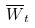Convert formula to latex. <formula><loc_0><loc_0><loc_500><loc_500>\overline { W } _ { t }</formula> 